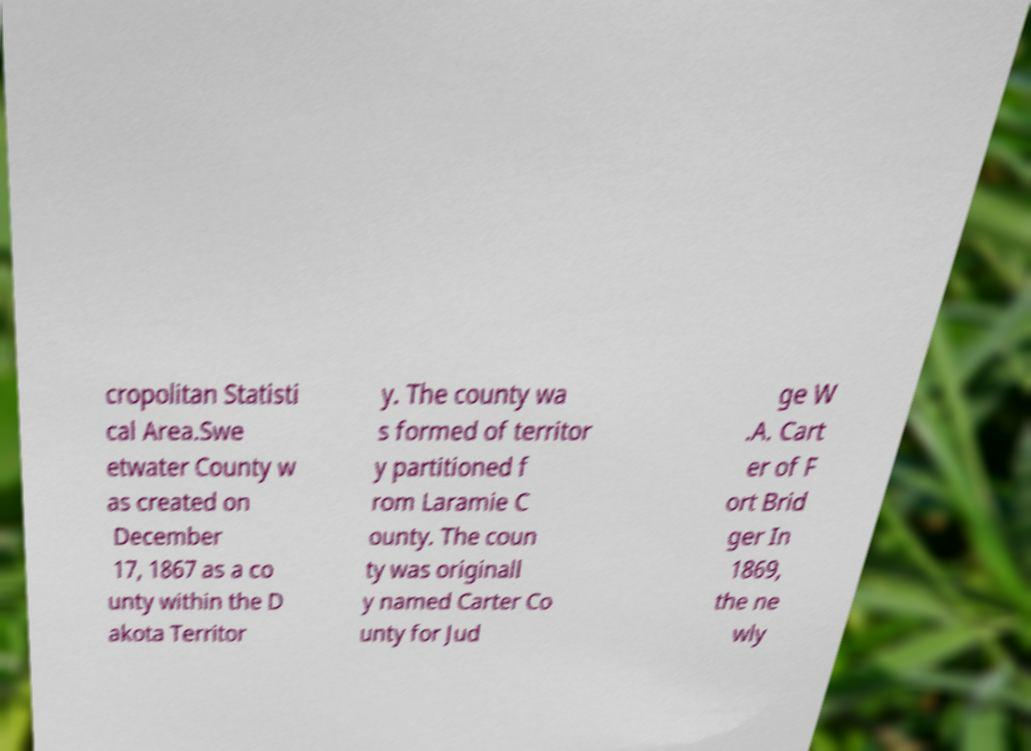Can you accurately transcribe the text from the provided image for me? cropolitan Statisti cal Area.Swe etwater County w as created on December 17, 1867 as a co unty within the D akota Territor y. The county wa s formed of territor y partitioned f rom Laramie C ounty. The coun ty was originall y named Carter Co unty for Jud ge W .A. Cart er of F ort Brid ger In 1869, the ne wly 